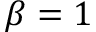<formula> <loc_0><loc_0><loc_500><loc_500>\beta = 1</formula> 